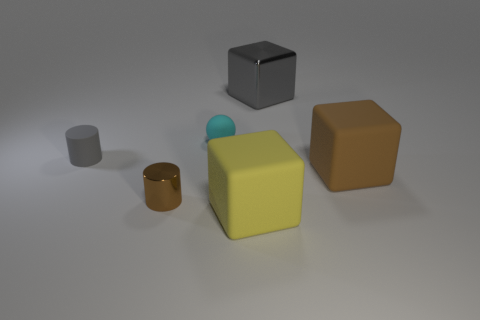There is another object that is the same shape as the small gray matte thing; what is it made of?
Your response must be concise. Metal. Are there an equal number of big gray metallic blocks in front of the ball and tiny purple objects?
Provide a succinct answer. Yes. What size is the matte object that is right of the tiny cyan matte ball and on the left side of the gray cube?
Offer a terse response. Large. Are there any other things that are the same color as the large shiny cube?
Provide a succinct answer. Yes. There is a shiny thing that is behind the gray object that is left of the large yellow matte thing; what size is it?
Make the answer very short. Large. What color is the thing that is both to the left of the tiny cyan matte thing and in front of the tiny gray rubber thing?
Make the answer very short. Brown. How many other objects are there of the same size as the gray matte cylinder?
Your answer should be compact. 2. Does the brown cylinder have the same size as the metal thing behind the large brown cube?
Your response must be concise. No. What color is the shiny cylinder that is the same size as the sphere?
Keep it short and to the point. Brown. What size is the shiny cylinder?
Offer a terse response. Small. 